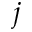<formula> <loc_0><loc_0><loc_500><loc_500>j</formula> 